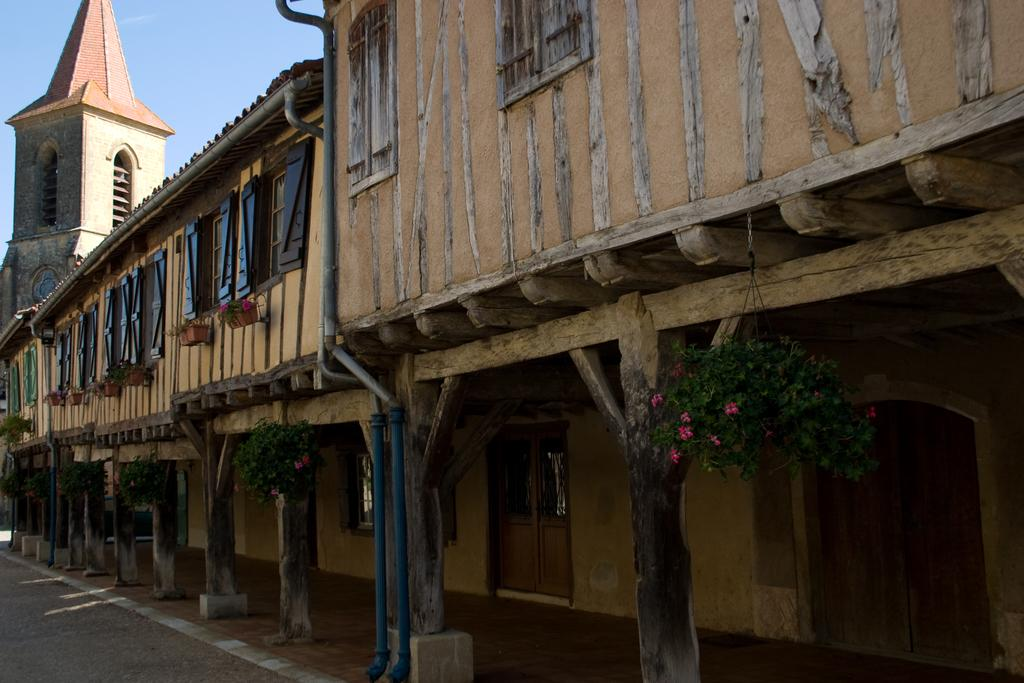What type of structure is present in the image? There is a building in the image. What can be seen growing in the image? There are plants in the image. What architectural features are visible in the image? There are windows and doors in the image. What other objects can be seen in the image? There are pipes in the image. What is visible in the background of the image? The sky is visible in the background of the image. What type of apples are hanging from the pipes in the image? There are no apples present in the image; the pipes are not associated with any fruit. 